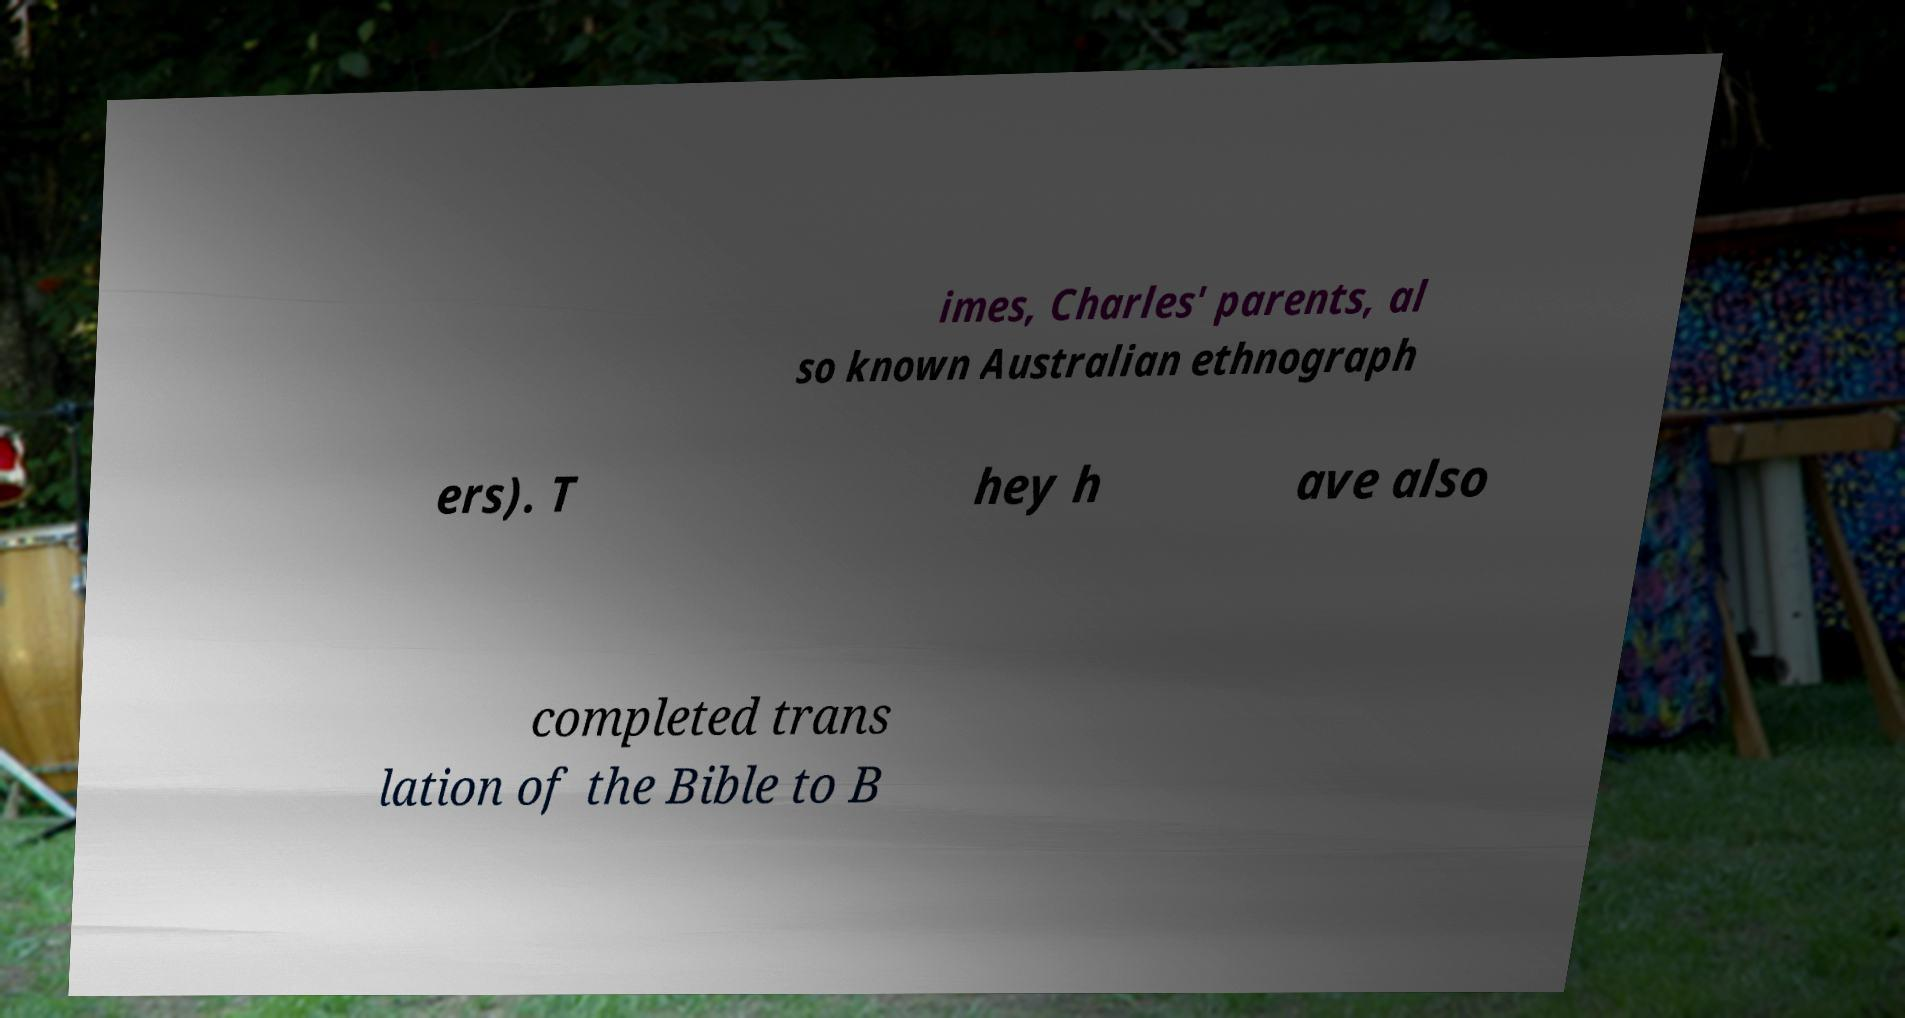There's text embedded in this image that I need extracted. Can you transcribe it verbatim? imes, Charles' parents, al so known Australian ethnograph ers). T hey h ave also completed trans lation of the Bible to B 